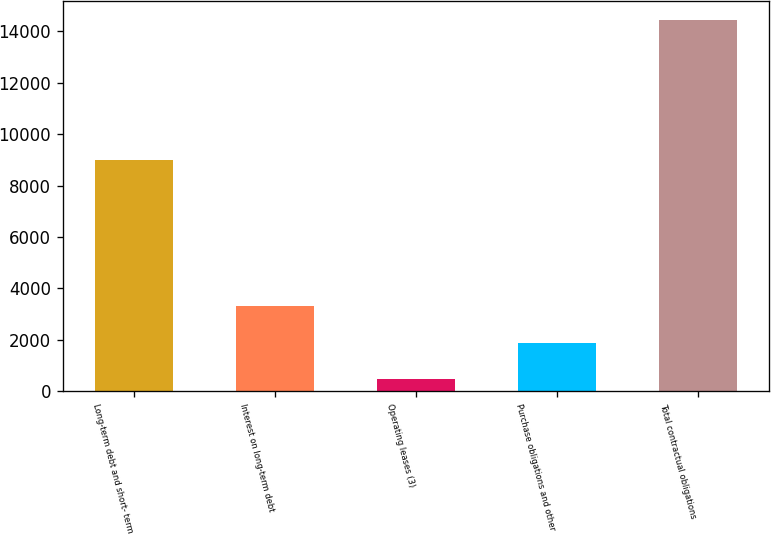Convert chart. <chart><loc_0><loc_0><loc_500><loc_500><bar_chart><fcel>Long-term debt and short- term<fcel>Interest on long-term debt<fcel>Operating leases (3)<fcel>Purchase obligations and other<fcel>Total contractual obligations<nl><fcel>9005<fcel>3322<fcel>489<fcel>1883.8<fcel>14437<nl></chart> 